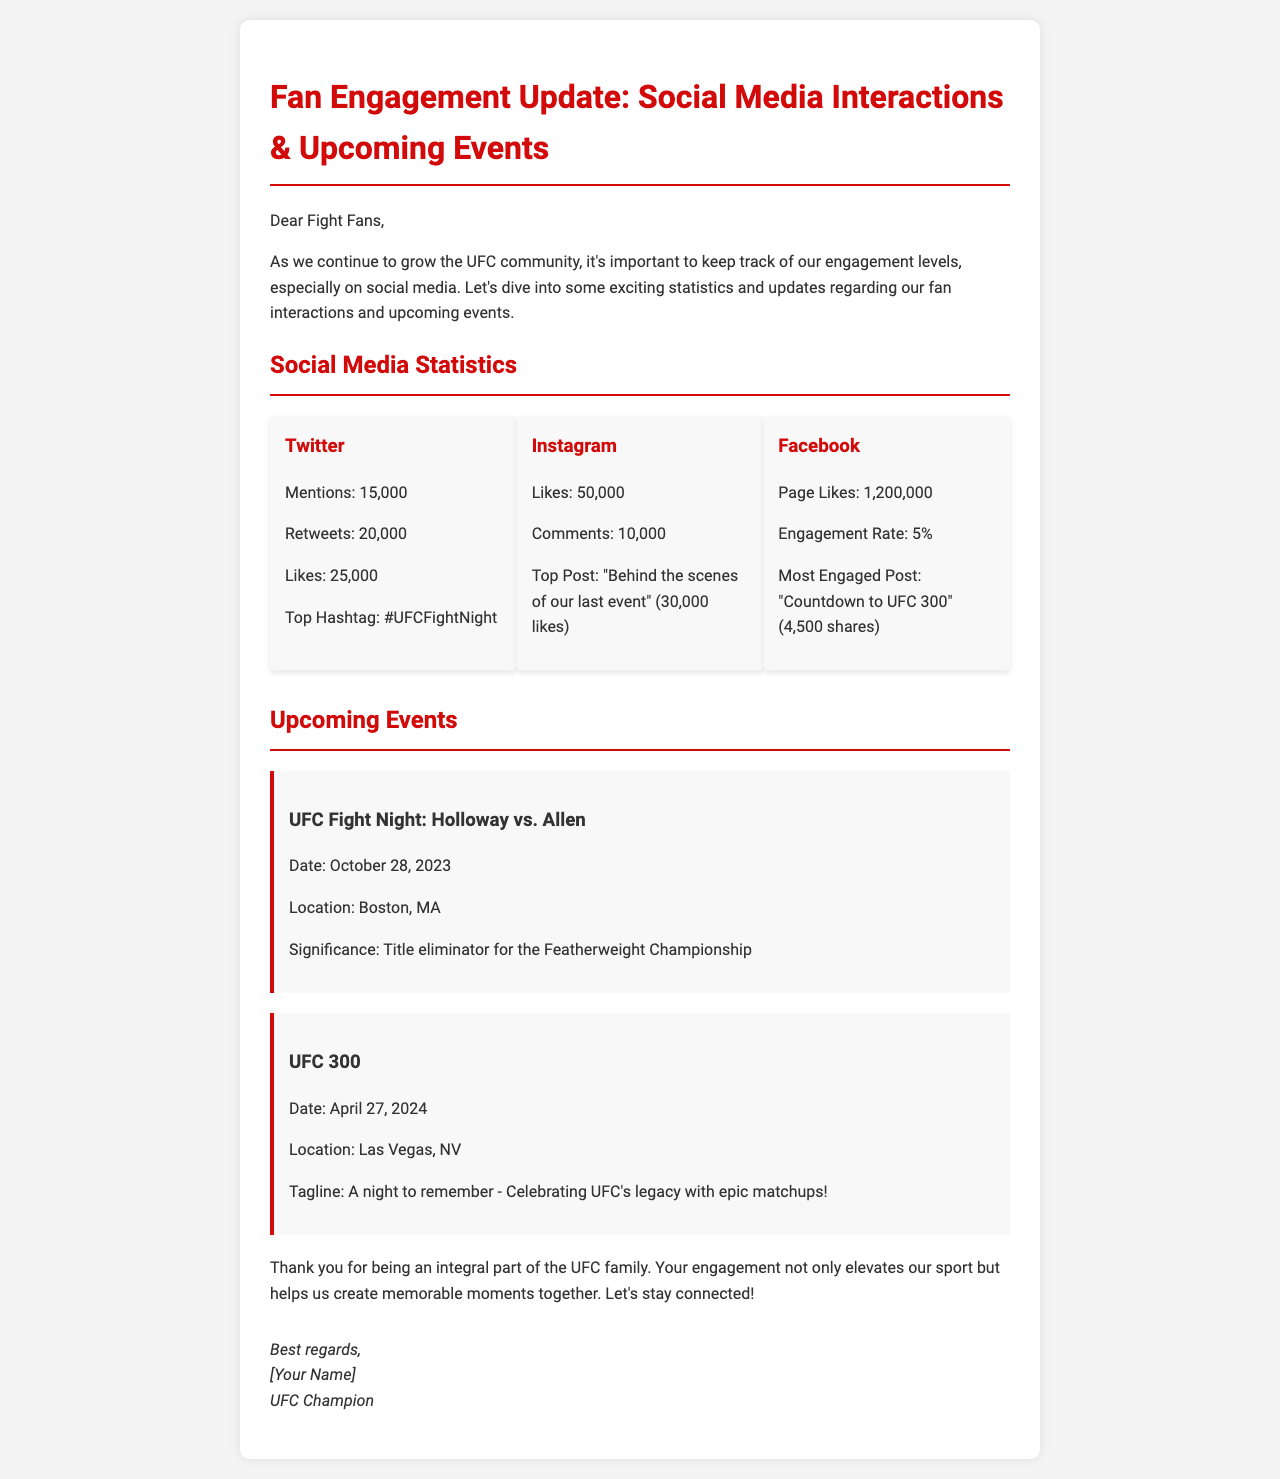What is the most mentioned hashtag on Twitter? The document specifies that the top hashtag used on Twitter is #UFCFightNight.
Answer: #UFCFightNight How many likes did the top Instagram post receive? The document states that the top post on Instagram, which is "Behind the scenes of our last event," received 30,000 likes.
Answer: 30,000 What is the date of UFC Fight Night: Holloway vs. Allen? According to the document, the date for this event is October 28, 2023.
Answer: October 28, 2023 What is the engagement rate on Facebook? The engagement rate on Facebook is explicitly mentioned in the document as 5%.
Answer: 5% How many retweets were recorded on Twitter? The document indicates that there were 20,000 retweets on Twitter.
Answer: 20,000 What is the significance of UFC Fight Night on October 28, 2023? The document highlights that this fight is a title eliminator for the Featherweight Championship.
Answer: Title eliminator for the Featherweight Championship Which event has a tagline focusing on celebrating UFC's legacy? The event UFC 300 has the tagline "A night to remember - Celebrating UFC's legacy with epic matchups!"
Answer: UFC 300 What is the name of the upcoming event on April 27, 2024? The document names UFC 300 as the upcoming event on this date.
Answer: UFC 300 What is the total number of page likes on Facebook? The document states that the Facebook page has 1,200,000 likes.
Answer: 1,200,000 